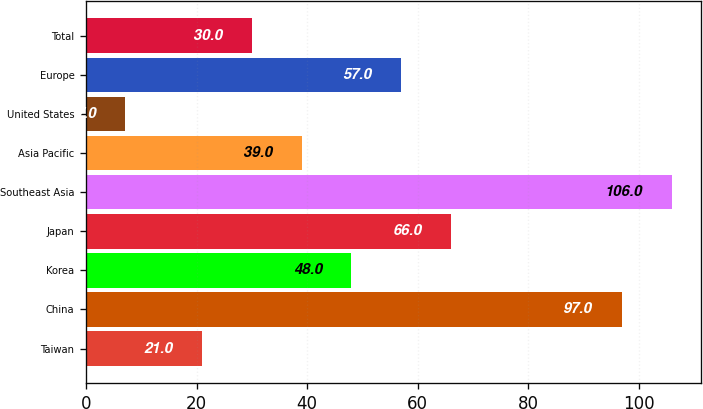Convert chart to OTSL. <chart><loc_0><loc_0><loc_500><loc_500><bar_chart><fcel>Taiwan<fcel>China<fcel>Korea<fcel>Japan<fcel>Southeast Asia<fcel>Asia Pacific<fcel>United States<fcel>Europe<fcel>Total<nl><fcel>21<fcel>97<fcel>48<fcel>66<fcel>106<fcel>39<fcel>7<fcel>57<fcel>30<nl></chart> 